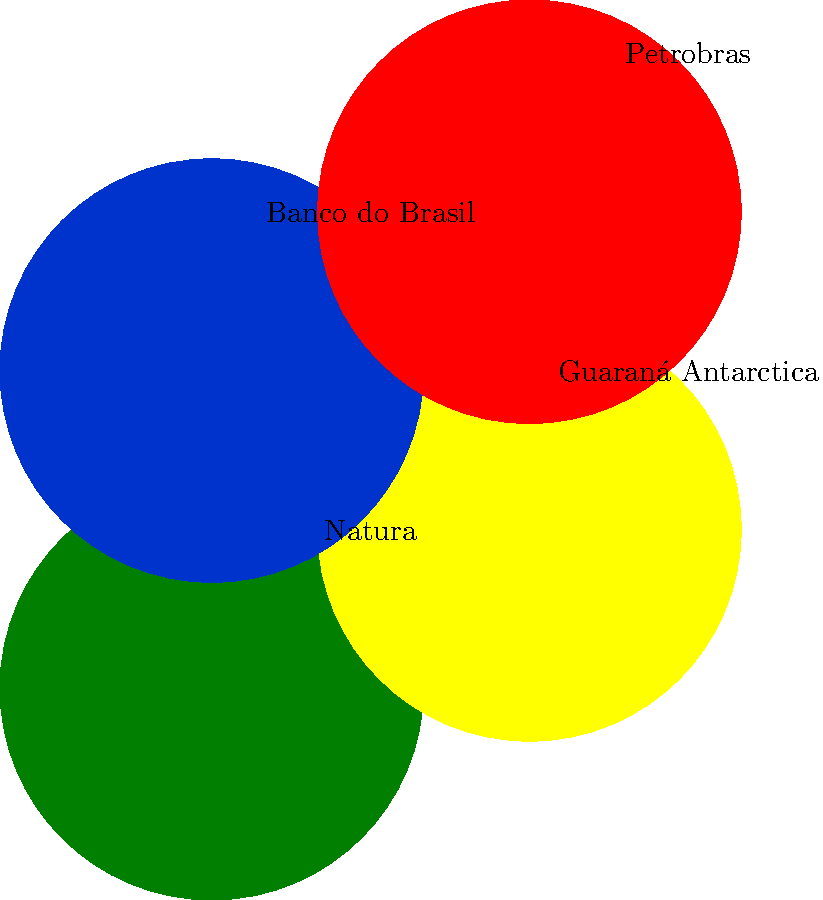Analyze the logos of these popular Brazilian brands. Which design element is most consistently used to resonate with local consumers? To answer this question, let's analyze the design elements of each logo:

1. Natura (green): Uses a natural, earthy green color, reflecting Brazil's rich biodiversity and eco-friendly values.

2. Guaraná Antarctica (yellow): Employs a vibrant yellow, reminiscent of Brazil's national colors and the energy associated with the guaraná fruit.

3. Banco do Brasil (blue and yellow): Utilizes the national colors of Brazil (blue and yellow), appealing to patriotic sentiments.

4. Petrobras (green and red): Incorporates green, again referencing Brazil's natural resources and environmental consciousness.

Analyzing these logos, we can see that:

- 3 out of 4 logos use green (Natura, Banco do Brasil, and Petrobras)
- 2 out of 4 logos use yellow (Guaraná Antarctica and Banco do Brasil)
- All logos use bright, vibrant colors

The most consistent design element across these logos is the use of colors that reflect Brazil's national identity, natural resources, and cultural values. Green, in particular, is the most frequently used color, appearing in 75% of the logos presented.

This use of color resonates with Brazilian consumers by:
1. Evoking national pride
2. Reflecting the country's natural beauty and biodiversity
3. Appealing to environmental consciousness

Therefore, the most consistently used design element to resonate with local consumers is the strategic use of colors, particularly green, that reflect Brazilian national identity and values.
Answer: Strategic use of colors reflecting Brazilian identity and values, especially green 